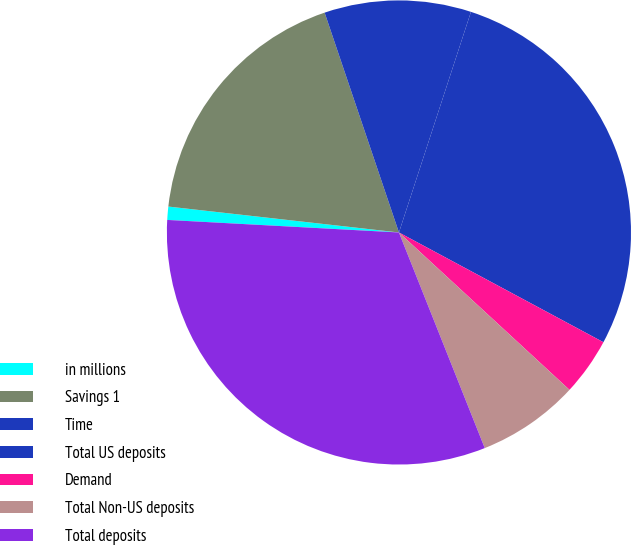Convert chart. <chart><loc_0><loc_0><loc_500><loc_500><pie_chart><fcel>in millions<fcel>Savings 1<fcel>Time<fcel>Total US deposits<fcel>Demand<fcel>Total Non-US deposits<fcel>Total deposits<nl><fcel>0.92%<fcel>18.03%<fcel>10.21%<fcel>27.82%<fcel>4.02%<fcel>7.11%<fcel>31.89%<nl></chart> 